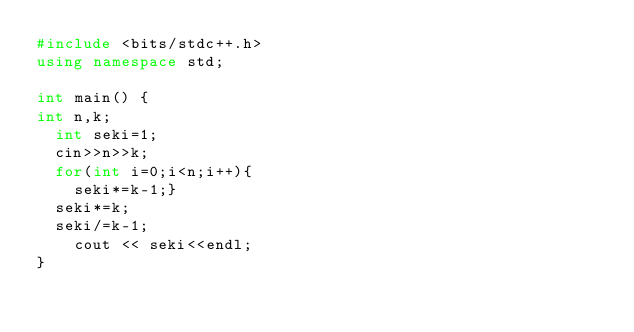Convert code to text. <code><loc_0><loc_0><loc_500><loc_500><_C++_>#include <bits/stdc++.h>
using namespace std;

int main() {
int n,k;
  int seki=1;
  cin>>n>>k;
  for(int i=0;i<n;i++){
    seki*=k-1;}
  seki*=k;
  seki/=k-1;
    cout << seki<<endl;
}
</code> 